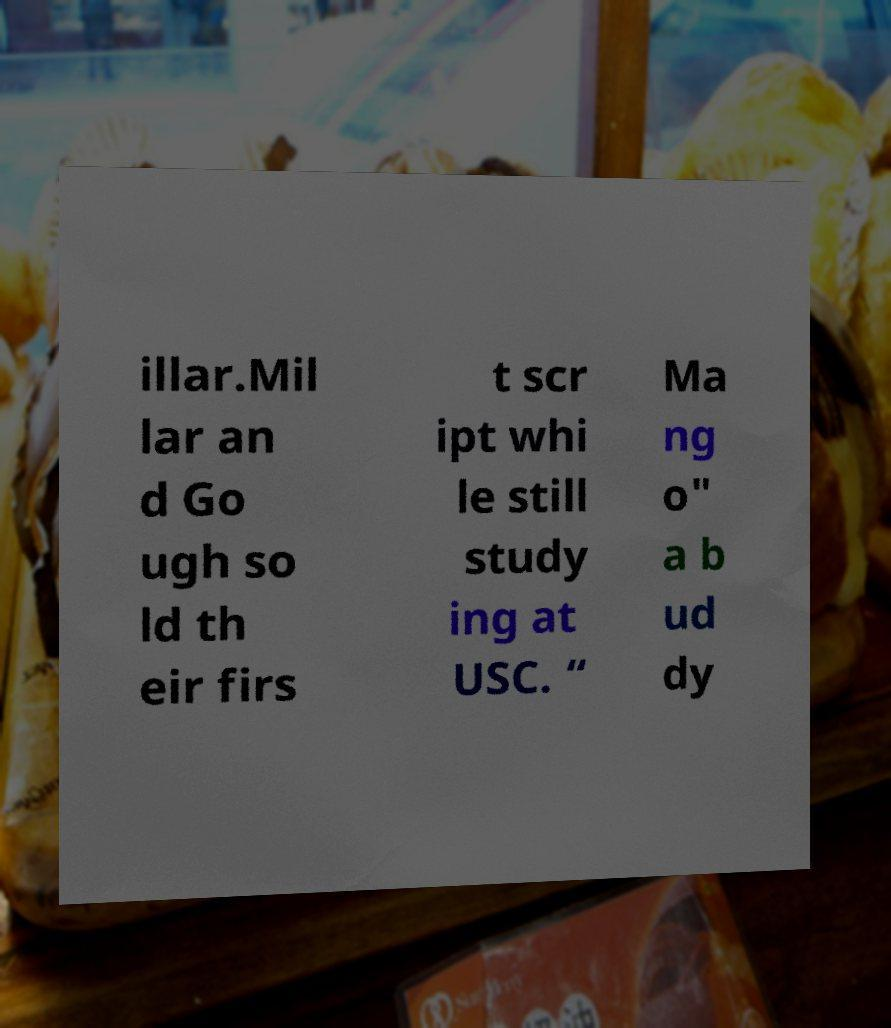There's text embedded in this image that I need extracted. Can you transcribe it verbatim? illar.Mil lar an d Go ugh so ld th eir firs t scr ipt whi le still study ing at USC. “ Ma ng o" a b ud dy 